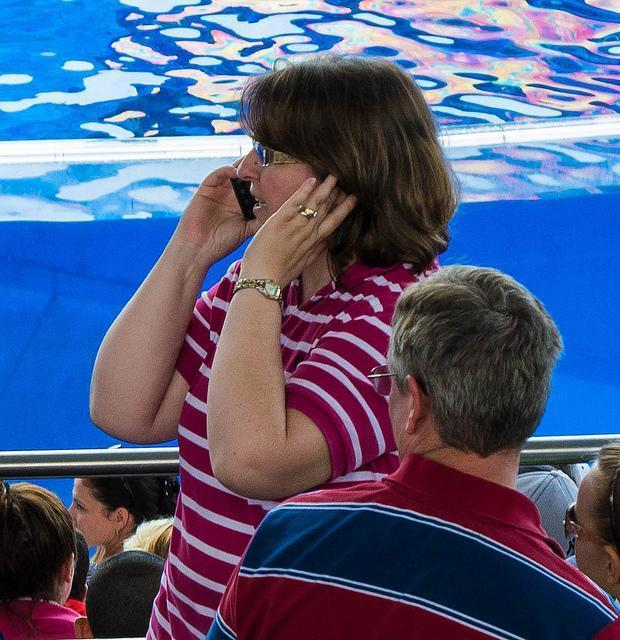How many people are there?
Give a very brief answer. 6. How many orange buttons on the toilet?
Give a very brief answer. 0. 